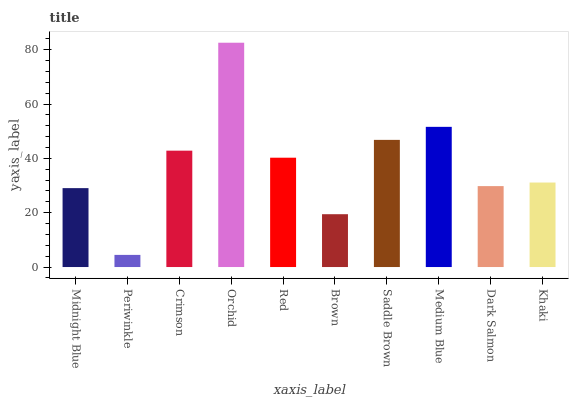Is Periwinkle the minimum?
Answer yes or no. Yes. Is Orchid the maximum?
Answer yes or no. Yes. Is Crimson the minimum?
Answer yes or no. No. Is Crimson the maximum?
Answer yes or no. No. Is Crimson greater than Periwinkle?
Answer yes or no. Yes. Is Periwinkle less than Crimson?
Answer yes or no. Yes. Is Periwinkle greater than Crimson?
Answer yes or no. No. Is Crimson less than Periwinkle?
Answer yes or no. No. Is Red the high median?
Answer yes or no. Yes. Is Khaki the low median?
Answer yes or no. Yes. Is Orchid the high median?
Answer yes or no. No. Is Periwinkle the low median?
Answer yes or no. No. 